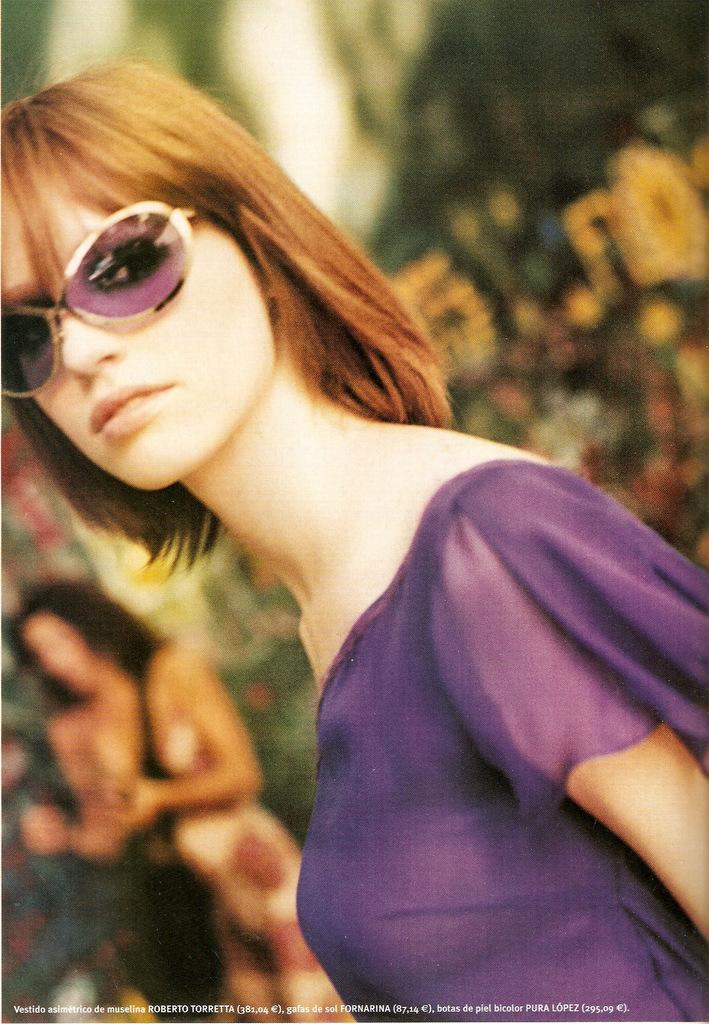Who or what is the main subject of the image? There is a person in the image. What can be observed about the background of the image? The background of the image is blurred. What is the person in the image wearing? The person is wearing clothes and sunglasses. What type of company can be seen in the background of the image? There is no company visible in the image; the background is blurred. What kind of sofa is the person sitting on in the image? There is no sofa present in the image; it only features a person. Can you hear any thunder in the image? There is no sound in the image, so it is impossible to determine if there is thunder or not. 